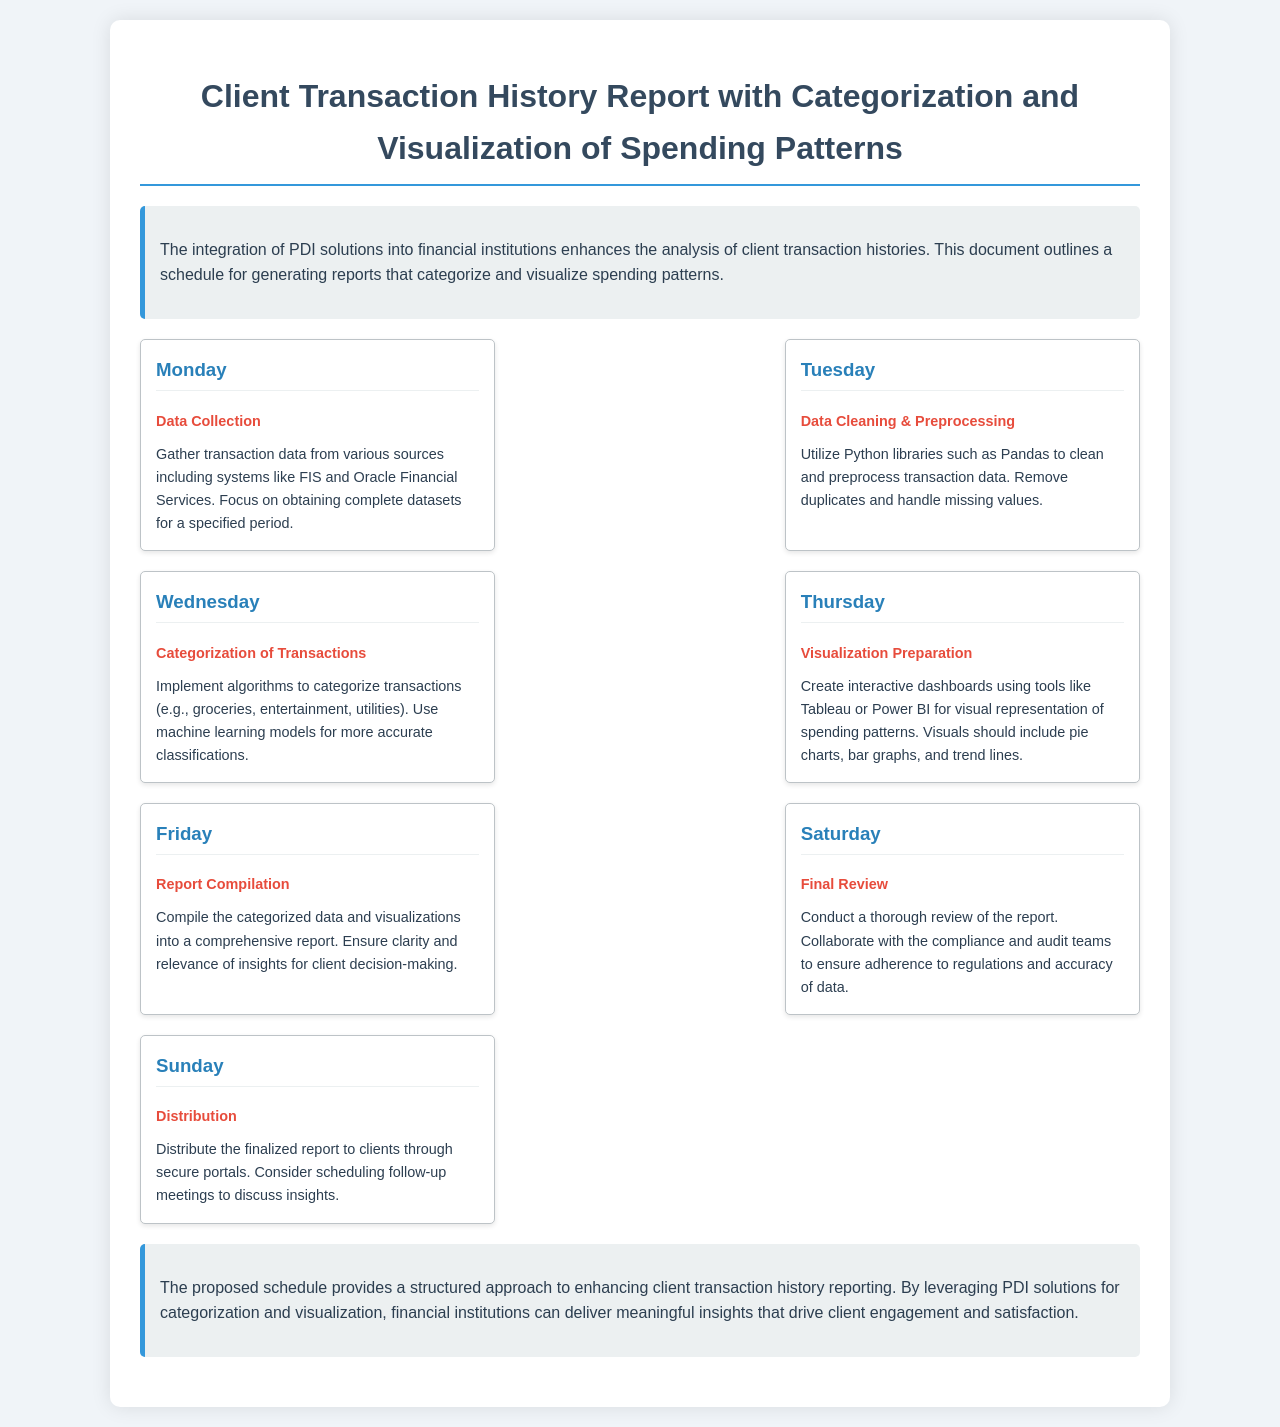What is the title of the report? The title of the report is outlined at the top of the document, stating the purpose of the report.
Answer: Client Transaction History Report with Categorization and Visualization of Spending Patterns How many days are dedicated to the report schedule? The schedule lists activities for each day of the week, indicating a total of seven days.
Answer: Seven days What activity is scheduled for Wednesday? The Wednesday activity is specifically mentioned in the document under that day's heading.
Answer: Categorization of Transactions Which tools are suggested for visualization preparation? The document names specific tools for creating visualizations, emphasizing popular options.
Answer: Tableau or Power BI What is the main activity for Friday? The Friday activity is highlighted in the schedule and focuses on the culmination of the week's work.
Answer: Report Compilation Who should be involved in the final review? The final review process is stated to involve certain teams as per the document's details.
Answer: Compliance and audit teams What type of charts are recommended for visual representation? The document specifies the types of visuals to be prepared for representation of spending patterns.
Answer: Pie charts, bar graphs, and trend lines What should be done on Sunday after report completion? The document indicates a crucial step to be taken after the report is finalized on Sunday.
Answer: Distribution 